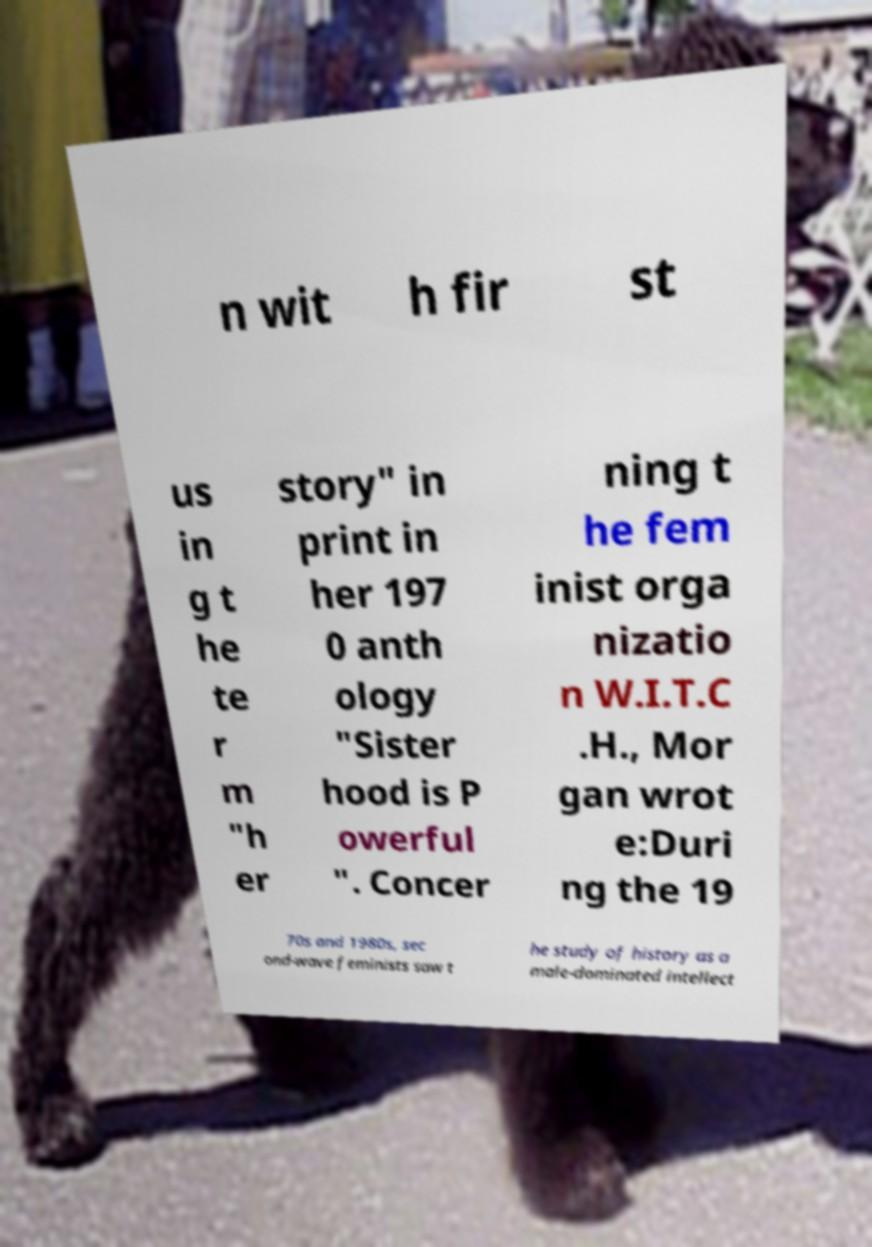For documentation purposes, I need the text within this image transcribed. Could you provide that? n wit h fir st us in g t he te r m "h er story" in print in her 197 0 anth ology "Sister hood is P owerful ". Concer ning t he fem inist orga nizatio n W.I.T.C .H., Mor gan wrot e:Duri ng the 19 70s and 1980s, sec ond-wave feminists saw t he study of history as a male-dominated intellect 